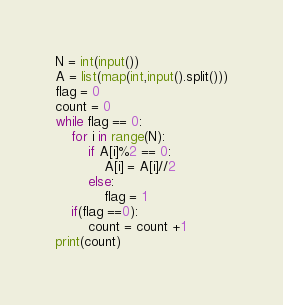Convert code to text. <code><loc_0><loc_0><loc_500><loc_500><_Python_>N = int(input())
A = list(map(int,input().split()))
flag = 0
count = 0
while flag == 0:
    for i in range(N):
        if A[i]%2 == 0:
            A[i] = A[i]//2
        else:
            flag = 1
    if(flag ==0):
        count = count +1
print(count)</code> 